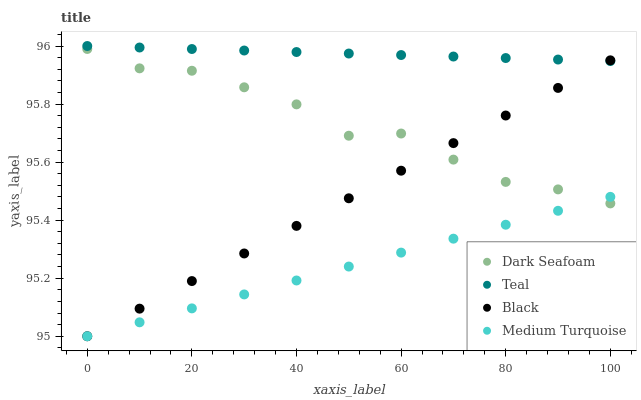Does Medium Turquoise have the minimum area under the curve?
Answer yes or no. Yes. Does Teal have the maximum area under the curve?
Answer yes or no. Yes. Does Black have the minimum area under the curve?
Answer yes or no. No. Does Black have the maximum area under the curve?
Answer yes or no. No. Is Medium Turquoise the smoothest?
Answer yes or no. Yes. Is Dark Seafoam the roughest?
Answer yes or no. Yes. Is Black the smoothest?
Answer yes or no. No. Is Black the roughest?
Answer yes or no. No. Does Black have the lowest value?
Answer yes or no. Yes. Does Teal have the lowest value?
Answer yes or no. No. Does Teal have the highest value?
Answer yes or no. Yes. Does Black have the highest value?
Answer yes or no. No. Is Medium Turquoise less than Teal?
Answer yes or no. Yes. Is Teal greater than Dark Seafoam?
Answer yes or no. Yes. Does Dark Seafoam intersect Medium Turquoise?
Answer yes or no. Yes. Is Dark Seafoam less than Medium Turquoise?
Answer yes or no. No. Is Dark Seafoam greater than Medium Turquoise?
Answer yes or no. No. Does Medium Turquoise intersect Teal?
Answer yes or no. No. 